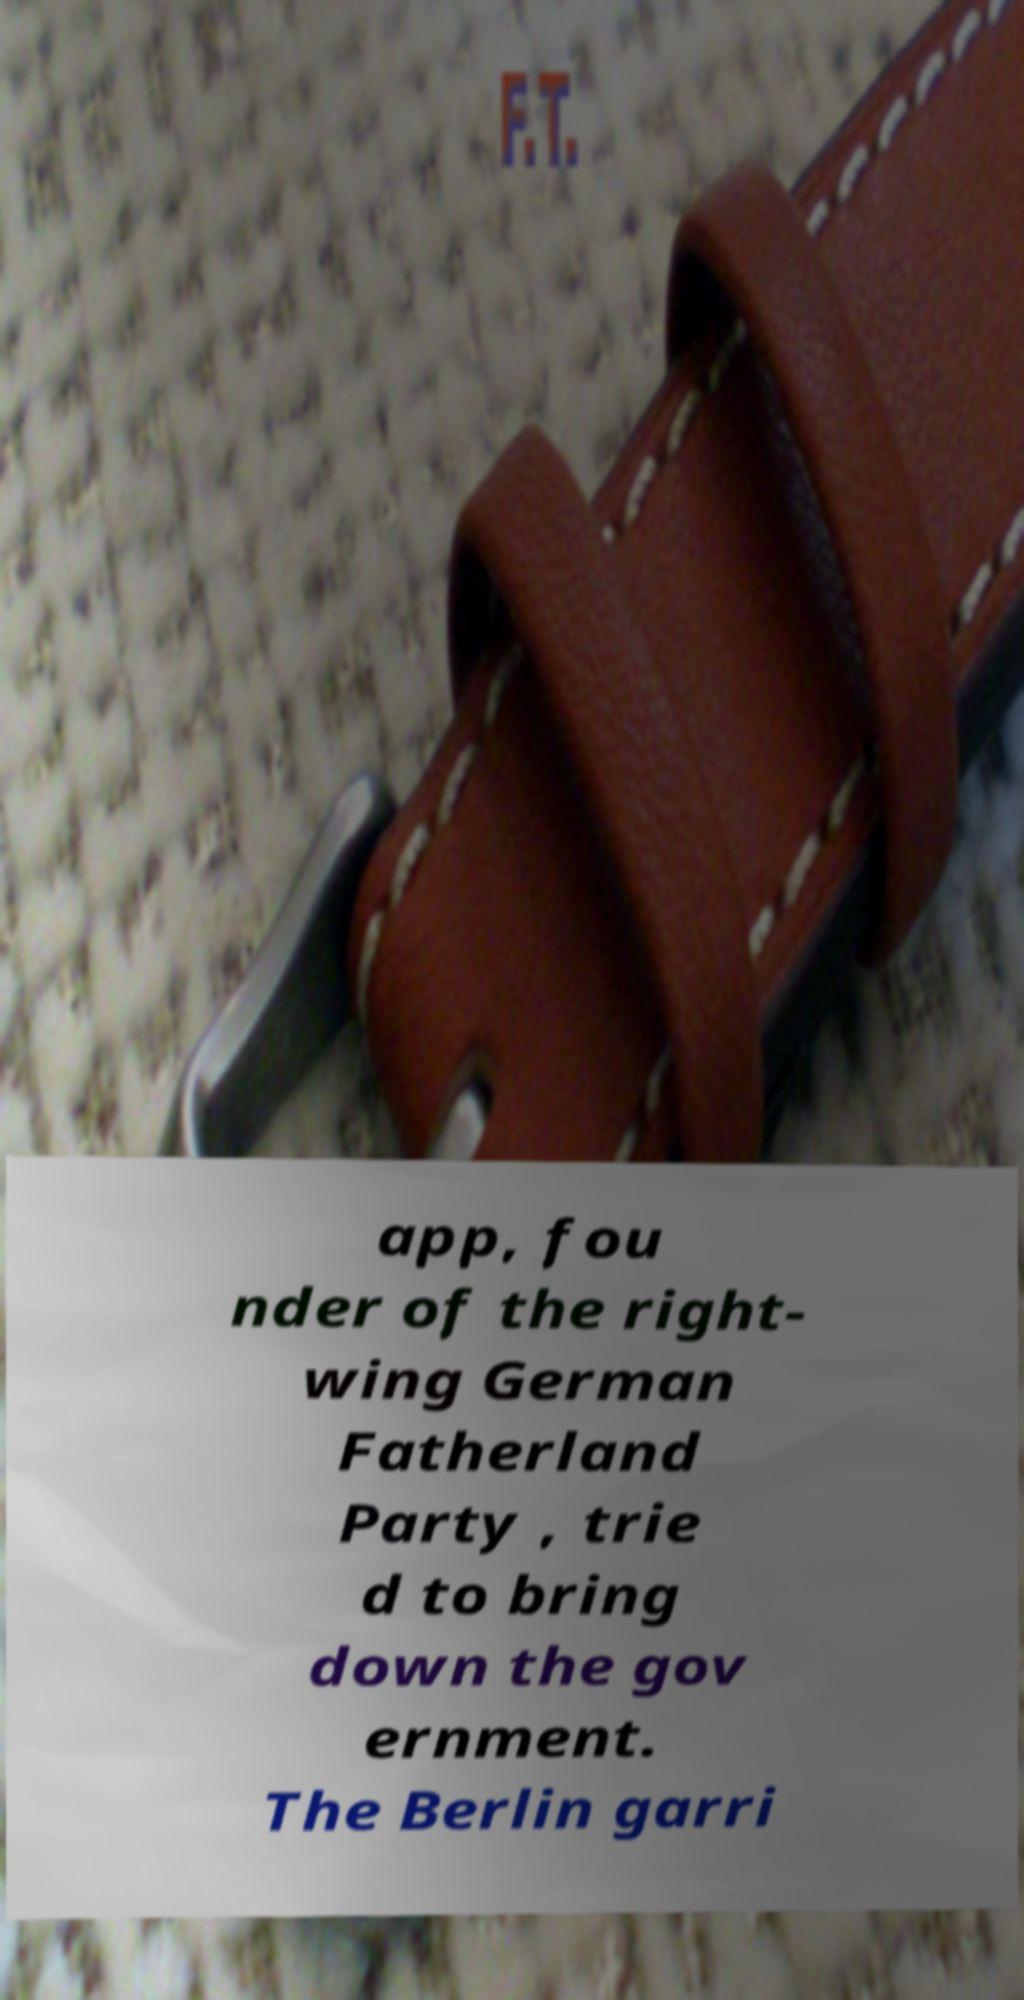Please identify and transcribe the text found in this image. app, fou nder of the right- wing German Fatherland Party , trie d to bring down the gov ernment. The Berlin garri 